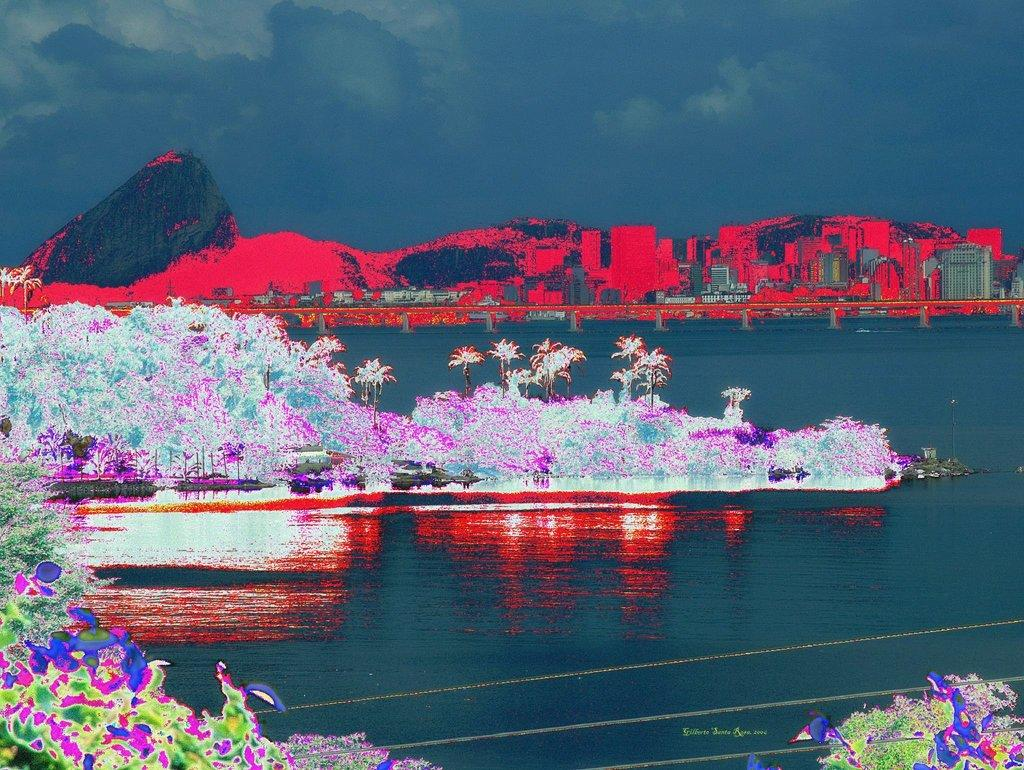What type of vegetation can be seen in the image? There are trees and plants in the image. What structure is present over the river in the image? There is a bridge over a river in the image. What type of landscape feature is visible in the image? There are hills in the image. What type of man-made structures can be seen in the image? There are buildings in the image. What is visible in the sky in the image? The sky is visible in the image, and there are clouds in the sky. Can you see any friends writing in a school in the image? There is no reference to friends, writing, or a school in the image. 